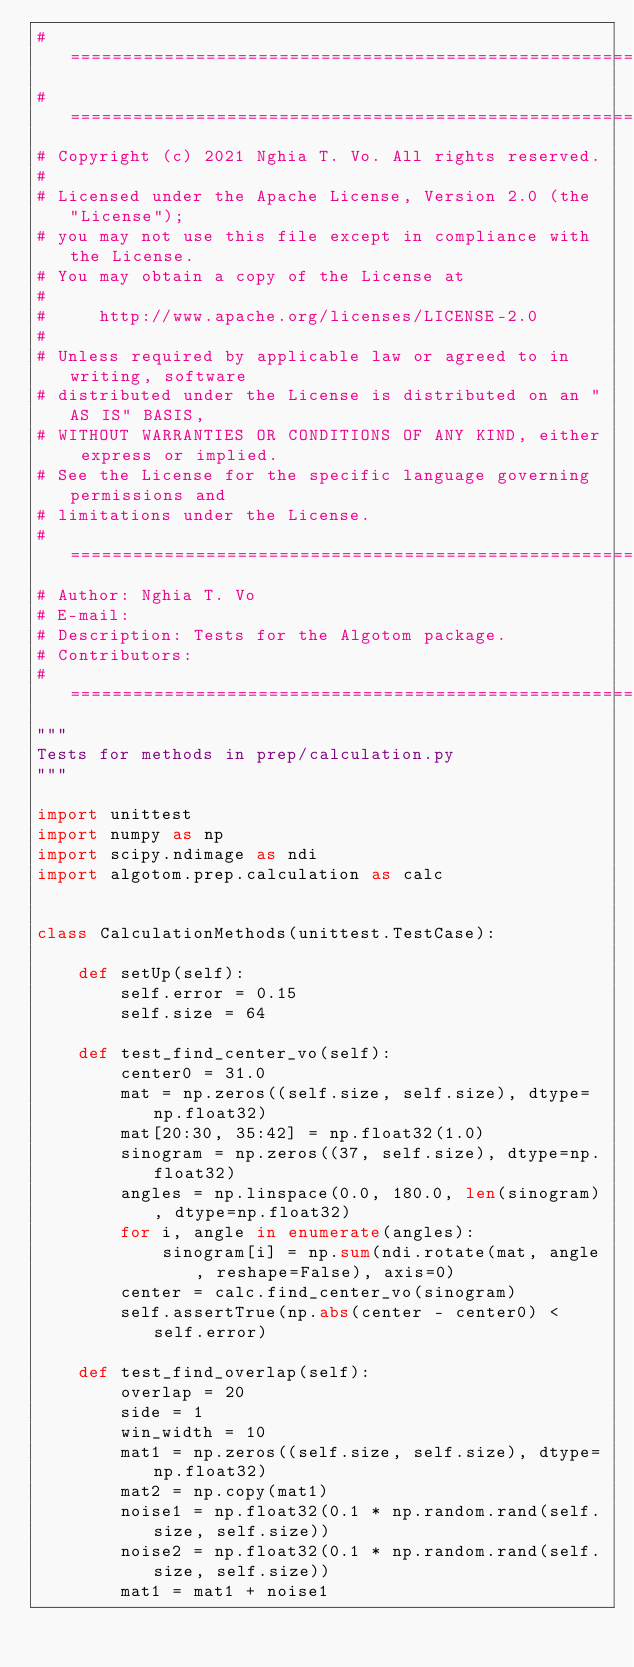Convert code to text. <code><loc_0><loc_0><loc_500><loc_500><_Python_># ============================================================================
# ============================================================================
# Copyright (c) 2021 Nghia T. Vo. All rights reserved.
#
# Licensed under the Apache License, Version 2.0 (the "License");
# you may not use this file except in compliance with the License.
# You may obtain a copy of the License at
#
#     http://www.apache.org/licenses/LICENSE-2.0
#
# Unless required by applicable law or agreed to in writing, software
# distributed under the License is distributed on an "AS IS" BASIS,
# WITHOUT WARRANTIES OR CONDITIONS OF ANY KIND, either express or implied.
# See the License for the specific language governing permissions and
# limitations under the License.
# ============================================================================
# Author: Nghia T. Vo
# E-mail:  
# Description: Tests for the Algotom package.
# Contributors:
# ============================================================================
"""
Tests for methods in prep/calculation.py
"""

import unittest
import numpy as np
import scipy.ndimage as ndi
import algotom.prep.calculation as calc


class CalculationMethods(unittest.TestCase):

    def setUp(self):
        self.error = 0.15
        self.size = 64

    def test_find_center_vo(self):
        center0 = 31.0
        mat = np.zeros((self.size, self.size), dtype=np.float32)
        mat[20:30, 35:42] = np.float32(1.0)
        sinogram = np.zeros((37, self.size), dtype=np.float32)
        angles = np.linspace(0.0, 180.0, len(sinogram), dtype=np.float32)
        for i, angle in enumerate(angles):
            sinogram[i] = np.sum(ndi.rotate(mat, angle, reshape=False), axis=0)
        center = calc.find_center_vo(sinogram)
        self.assertTrue(np.abs(center - center0) < self.error)

    def test_find_overlap(self):
        overlap = 20
        side = 1
        win_width = 10
        mat1 = np.zeros((self.size, self.size), dtype=np.float32)
        mat2 = np.copy(mat1)
        noise1 = np.float32(0.1 * np.random.rand(self.size, self.size))
        noise2 = np.float32(0.1 * np.random.rand(self.size, self.size))
        mat1 = mat1 + noise1</code> 